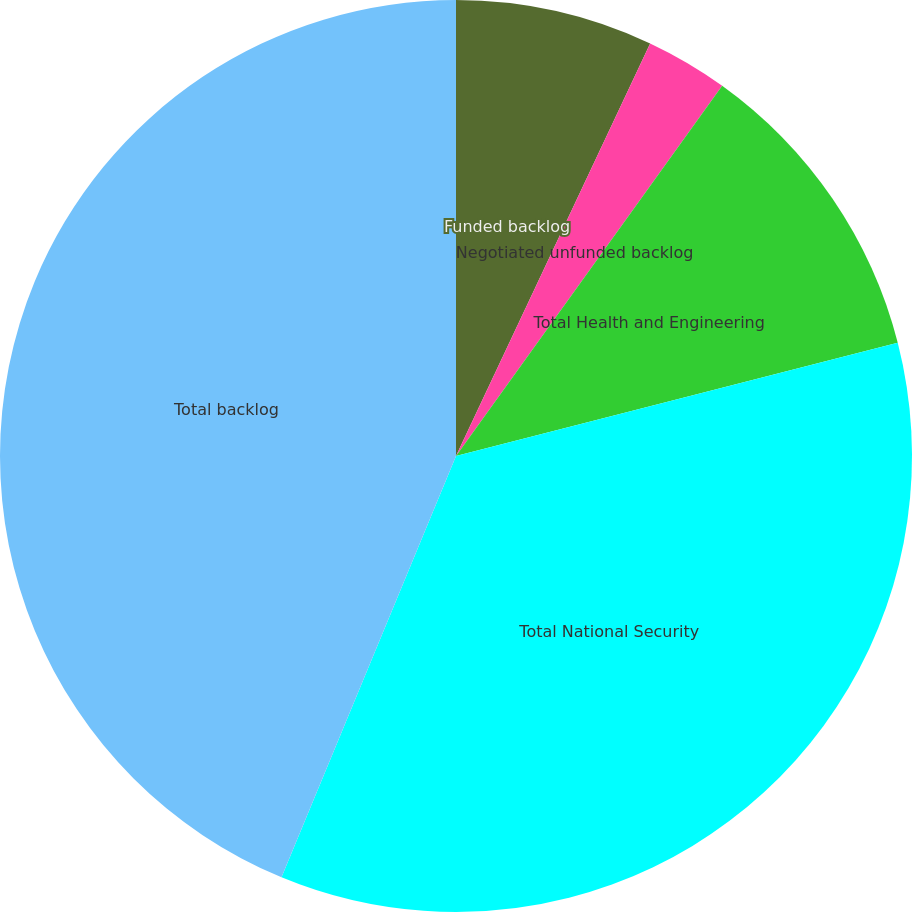<chart> <loc_0><loc_0><loc_500><loc_500><pie_chart><fcel>Funded backlog<fcel>Negotiated unfunded backlog<fcel>Total Health and Engineering<fcel>Total National Security<fcel>Total backlog<nl><fcel>7.0%<fcel>2.92%<fcel>11.09%<fcel>35.24%<fcel>43.75%<nl></chart> 